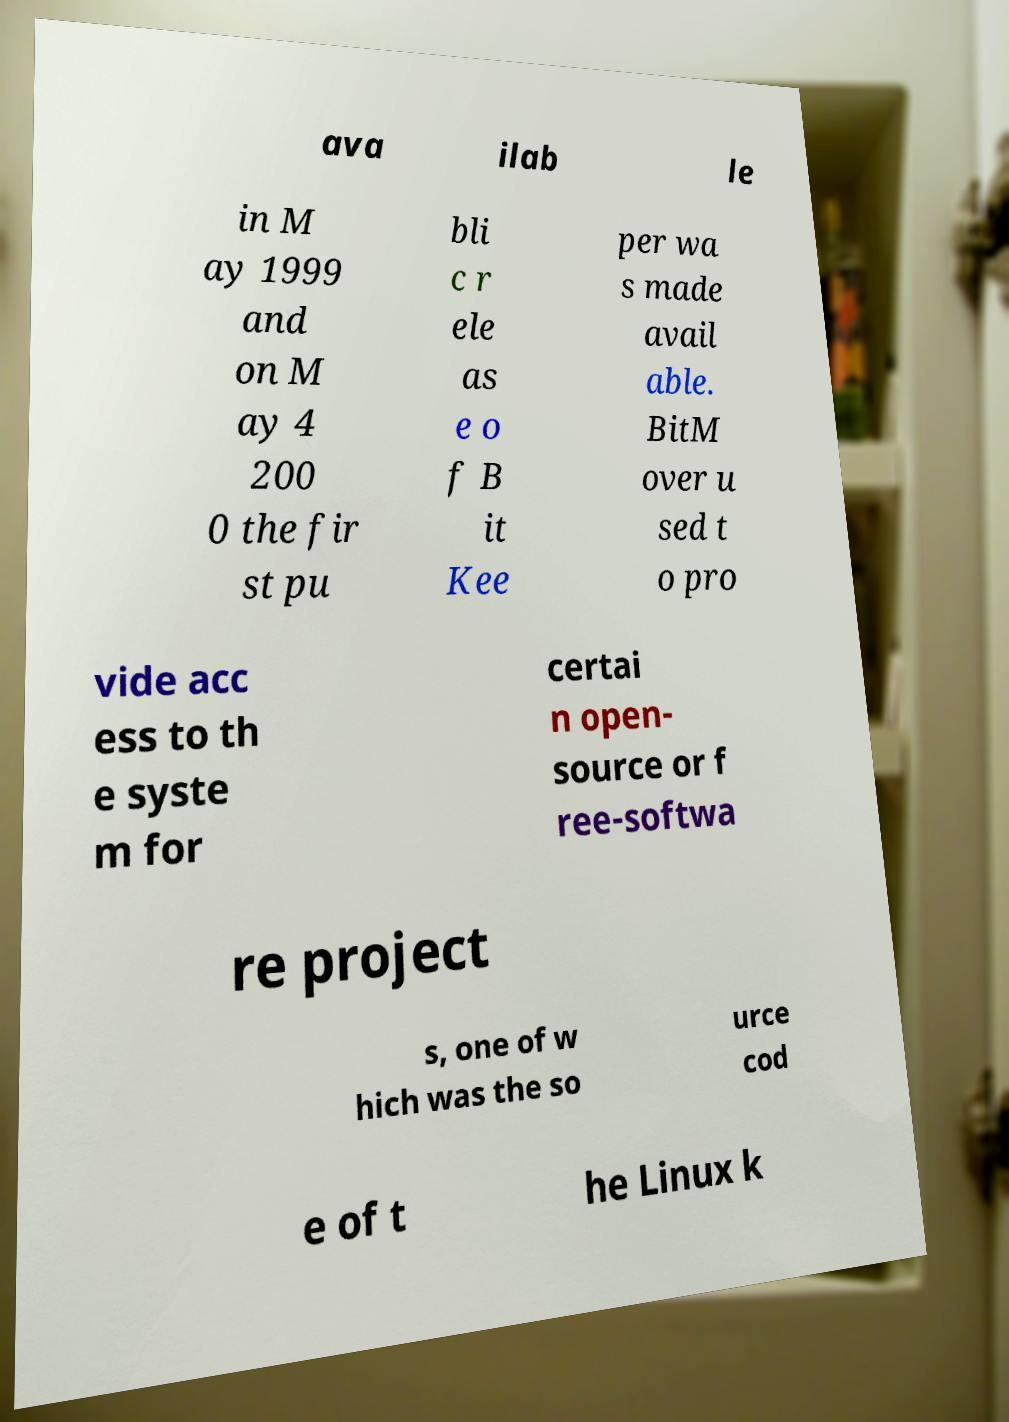Please read and relay the text visible in this image. What does it say? ava ilab le in M ay 1999 and on M ay 4 200 0 the fir st pu bli c r ele as e o f B it Kee per wa s made avail able. BitM over u sed t o pro vide acc ess to th e syste m for certai n open- source or f ree-softwa re project s, one of w hich was the so urce cod e of t he Linux k 